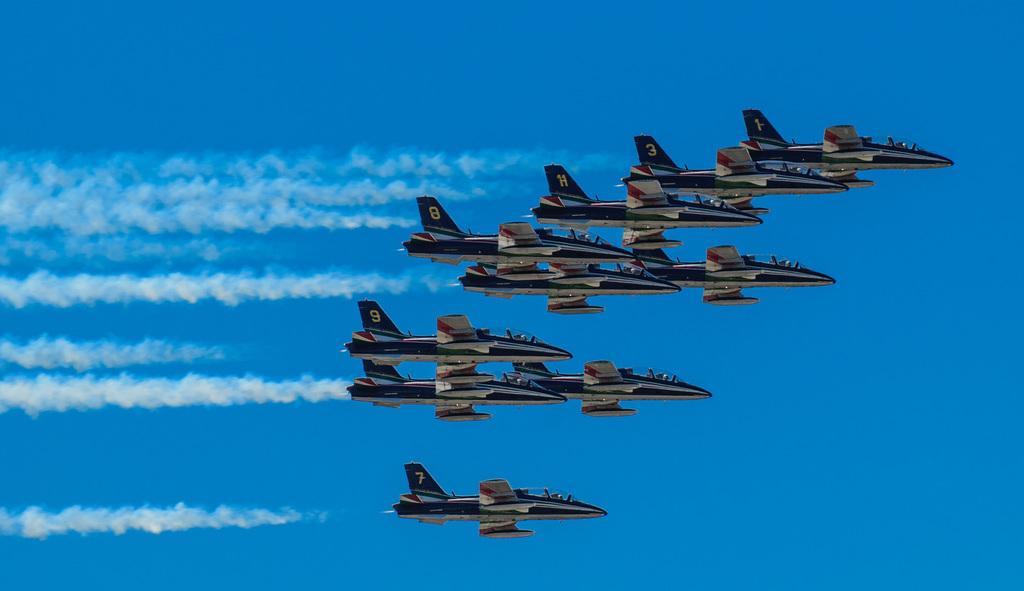Could you give a brief overview of what you see in this image? This is the image of jet planes and smoke. There is blue colored background. 